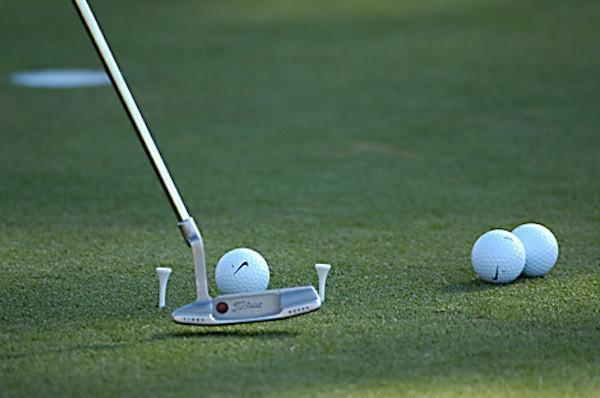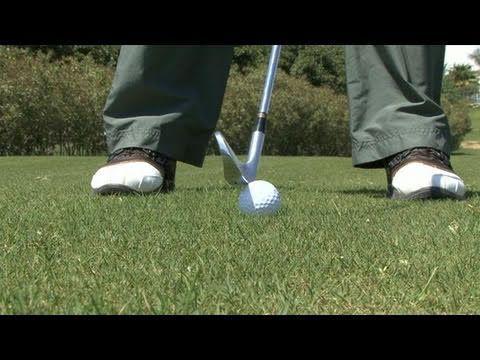The first image is the image on the left, the second image is the image on the right. For the images shown, is this caption "One image shows a golf club and three balls, but no part of a golfer." true? Answer yes or no. Yes. The first image is the image on the left, the second image is the image on the right. For the images displayed, is the sentence "The left image contains exactly three golf balls." factually correct? Answer yes or no. Yes. 